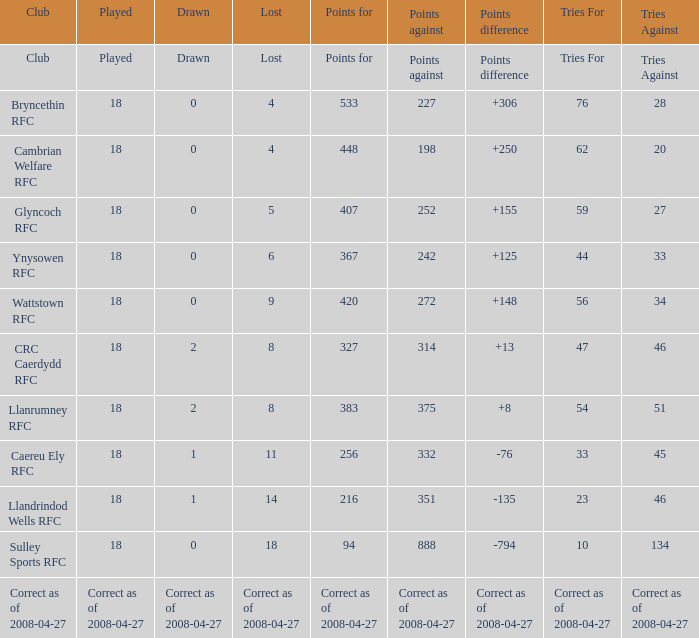What is the value for the item "Tries" when the value of the item "Played" is 18 and the value of the item "Points" is 375? 54.0. 